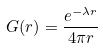<formula> <loc_0><loc_0><loc_500><loc_500>G ( r ) = \frac { e ^ { - \lambda r } } { 4 \pi r }</formula> 